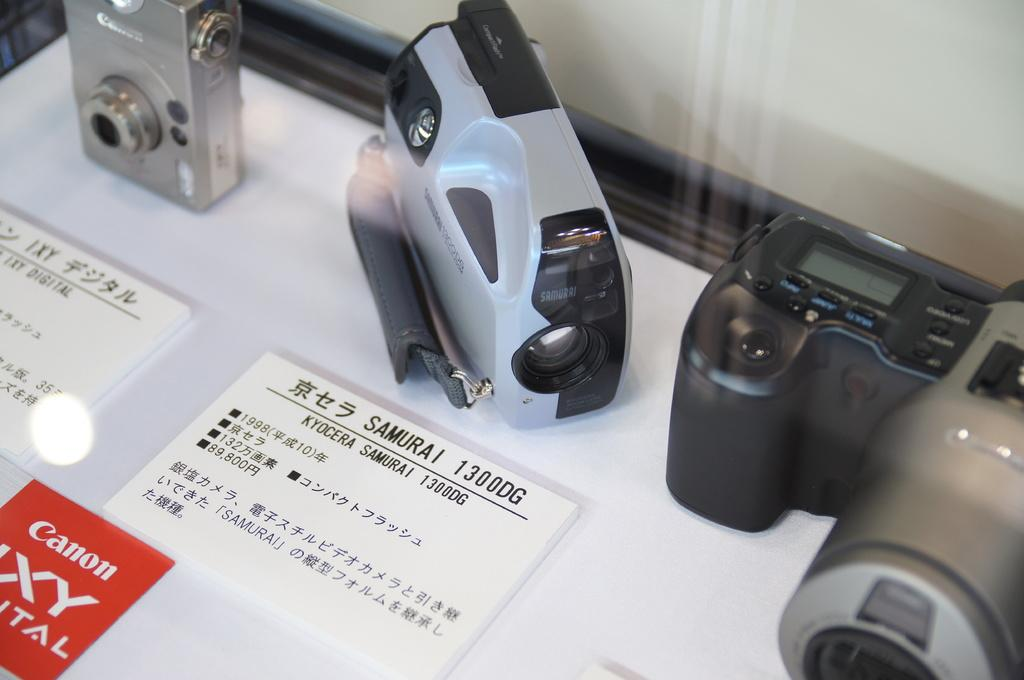What is the main subject of the image? The main subject of the image is three cameras in the foreground. How are the cameras displayed in the image? The cameras are placed inside a glass display. What additional information can be gathered from the display? Price tags are visible on the surface of the display, and the company logo is also present. What type of patch is being sewn onto the road in the image? There is no patch being sewn onto a road in the image; the image features three cameras inside a glass display. 